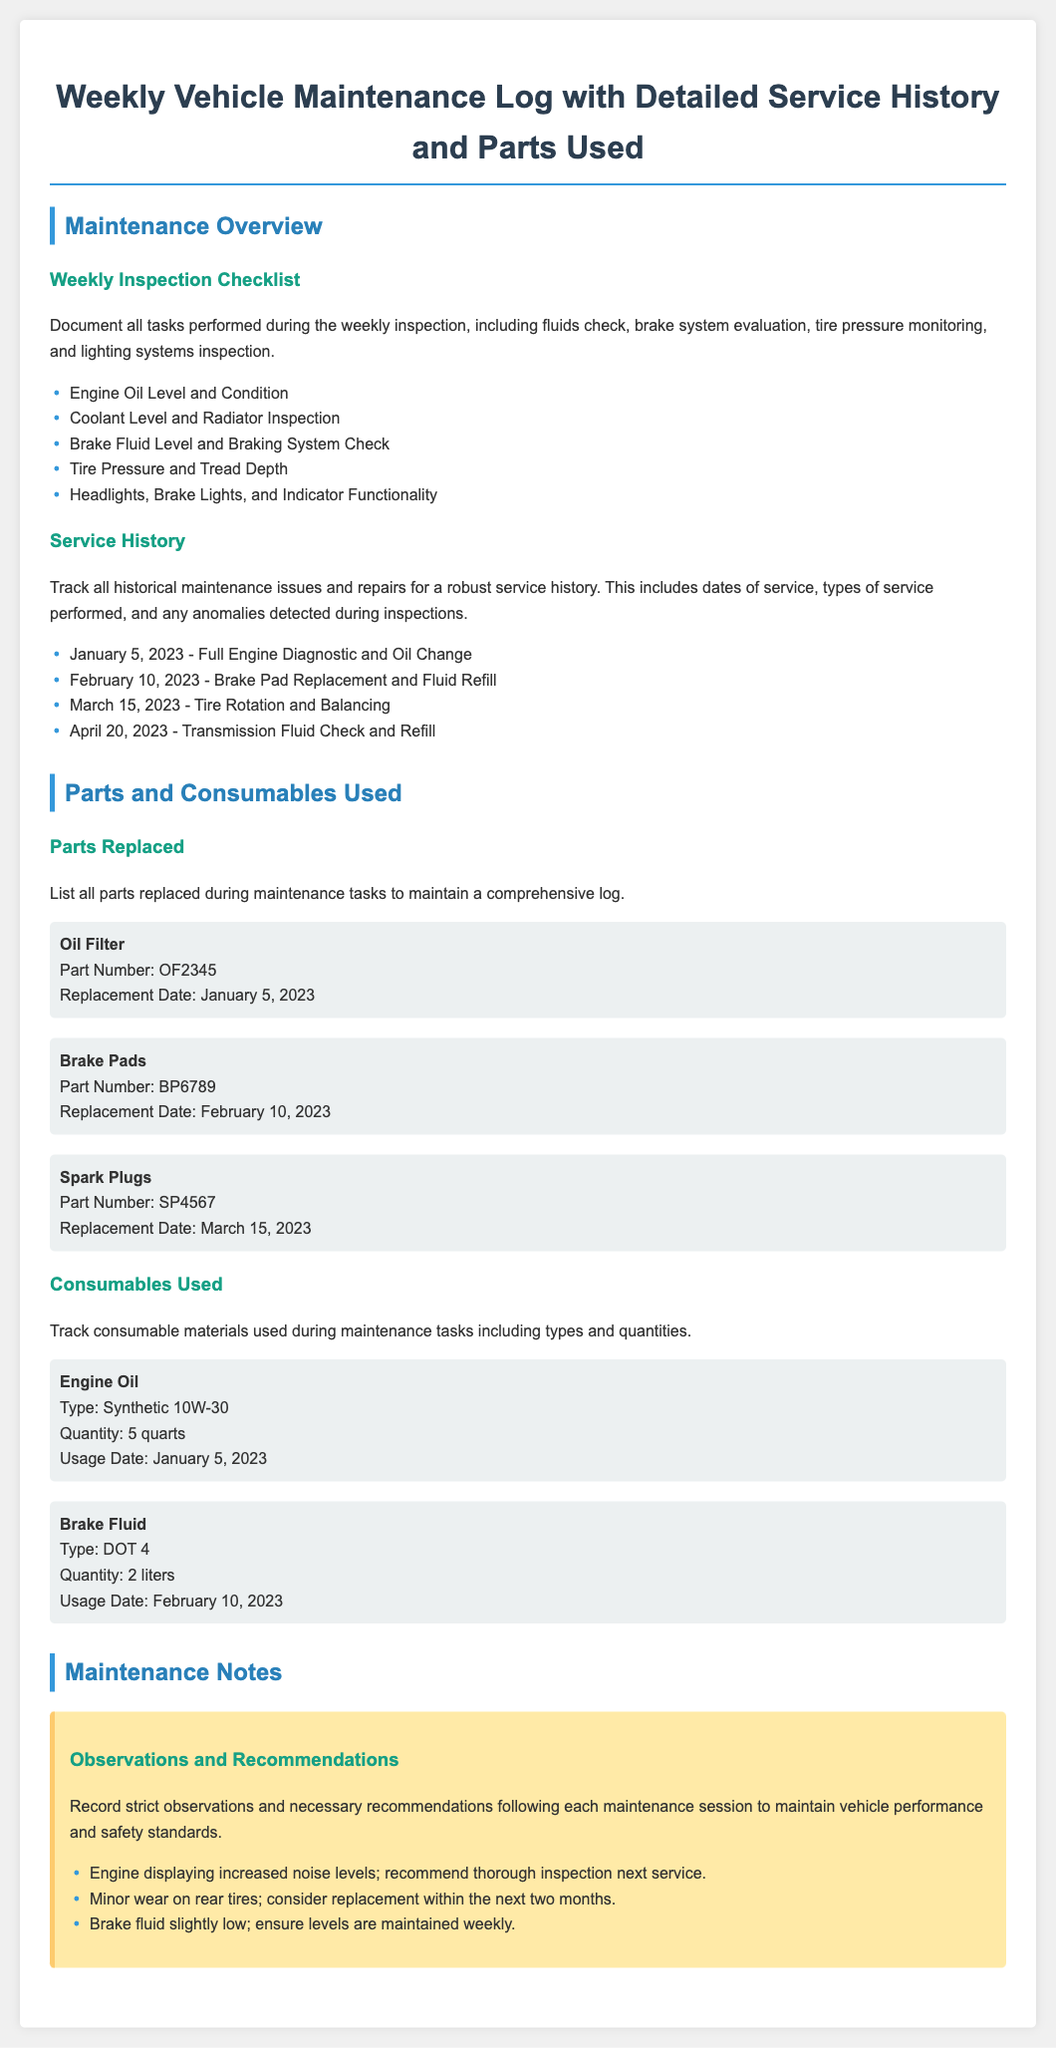What tasks are included in the weekly inspection checklist? The weekly inspection checklist includes tasks related to vehicle maintenance such as checking fluids, evaluating brake systems, monitoring tire pressure, and inspecting lighting systems.
Answer: Engine Oil Level and Condition, Coolant Level and Radiator Inspection, Brake Fluid Level and Braking System Check, Tire Pressure and Tread Depth, Headlights, Brake Lights, and Indicator Functionality What was the date of the last oil change? The last oil change was documented as part of the service history for January 5, 2023.
Answer: January 5, 2023 How many liters of brake fluid were used during maintenance? The quantity of brake fluid used during maintenance on February 10, 2023, is indicated in the consumables section.
Answer: 2 liters What type of engine oil was used? The type of engine oil used during maintenance is specified in the consumables section of the document.
Answer: Synthetic 10W-30 What maintenance issue should be inspected next? The document contains observations and recommendations for maintenance issues requiring attention during the next service.
Answer: Thorough inspection What part was replaced on March 15, 2023? The service history includes a record of parts replaced, including the specific part replaced on March 15, 2023.
Answer: Spark Plugs What is the significance of the service history section? The service history section is essential for tracking maintenance issues and repairs, including dates and types of service performed.
Answer: Track historical maintenance issues How many parts are listed under parts replaced? The document specifies a count of parts that were replaced during various maintenance tasks.
Answer: 3 parts 